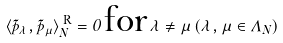Convert formula to latex. <formula><loc_0><loc_0><loc_500><loc_500>\langle \tilde { p } _ { \lambda } , \tilde { p } _ { \mu } \rangle _ { N } ^ { \text { R} } = 0 \, \text {for} \, \lambda \neq \mu \, ( \lambda , \mu \in \Lambda _ { N } )</formula> 